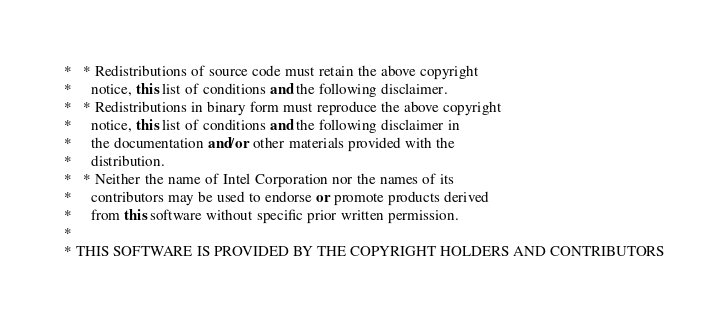<code> <loc_0><loc_0><loc_500><loc_500><_C++_> *   * Redistributions of source code must retain the above copyright
 *     notice, this list of conditions and the following disclaimer.
 *   * Redistributions in binary form must reproduce the above copyright
 *     notice, this list of conditions and the following disclaimer in
 *     the documentation and/or other materials provided with the
 *     distribution.
 *   * Neither the name of Intel Corporation nor the names of its
 *     contributors may be used to endorse or promote products derived
 *     from this software without specific prior written permission.
 *
 * THIS SOFTWARE IS PROVIDED BY THE COPYRIGHT HOLDERS AND CONTRIBUTORS</code> 